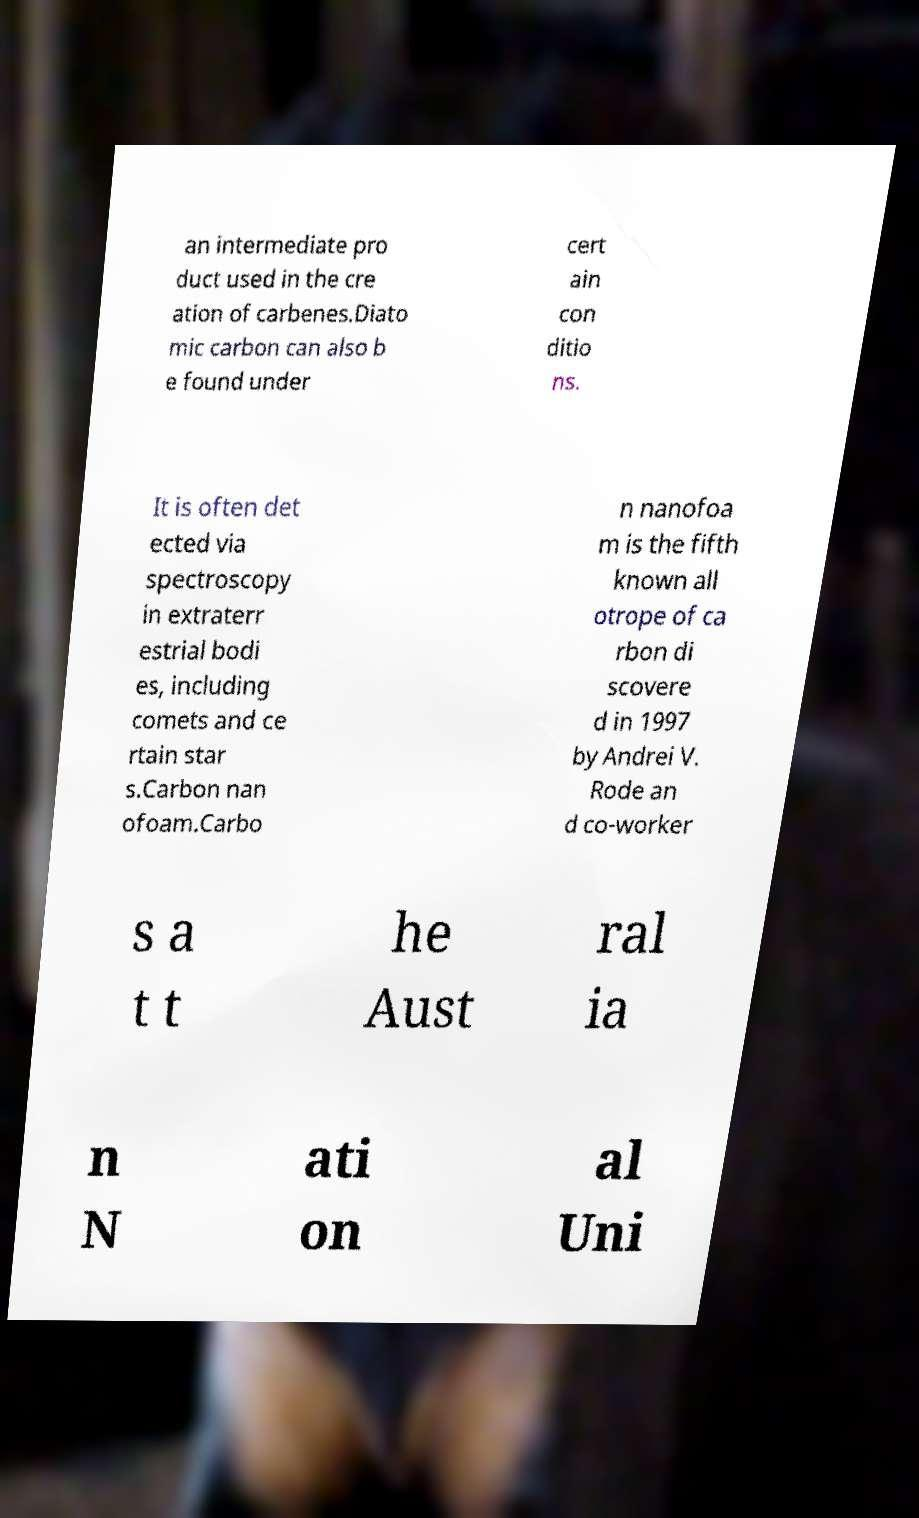For documentation purposes, I need the text within this image transcribed. Could you provide that? an intermediate pro duct used in the cre ation of carbenes.Diato mic carbon can also b e found under cert ain con ditio ns. It is often det ected via spectroscopy in extraterr estrial bodi es, including comets and ce rtain star s.Carbon nan ofoam.Carbo n nanofoa m is the fifth known all otrope of ca rbon di scovere d in 1997 by Andrei V. Rode an d co-worker s a t t he Aust ral ia n N ati on al Uni 